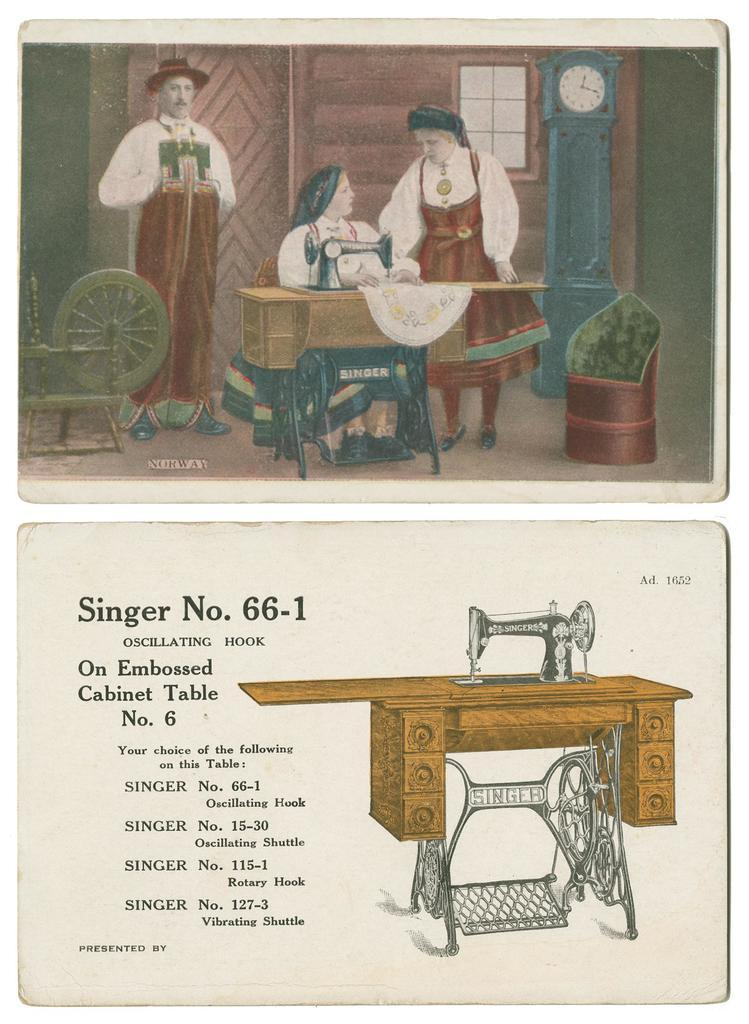What type of equipment is present in the image? There is a sewing machine in the image. What can be seen on the wall in the image? There is a clock on the wall in the image. What architectural feature is visible in the image? There is a window in the image. What type of furniture is in the image? There is a chair in the image. How many people are present in the image? There are three people in the image. What type of honey is being used to stick the fowl to the wall in the image? There is no honey, fowl, or any such activity present in the image. 